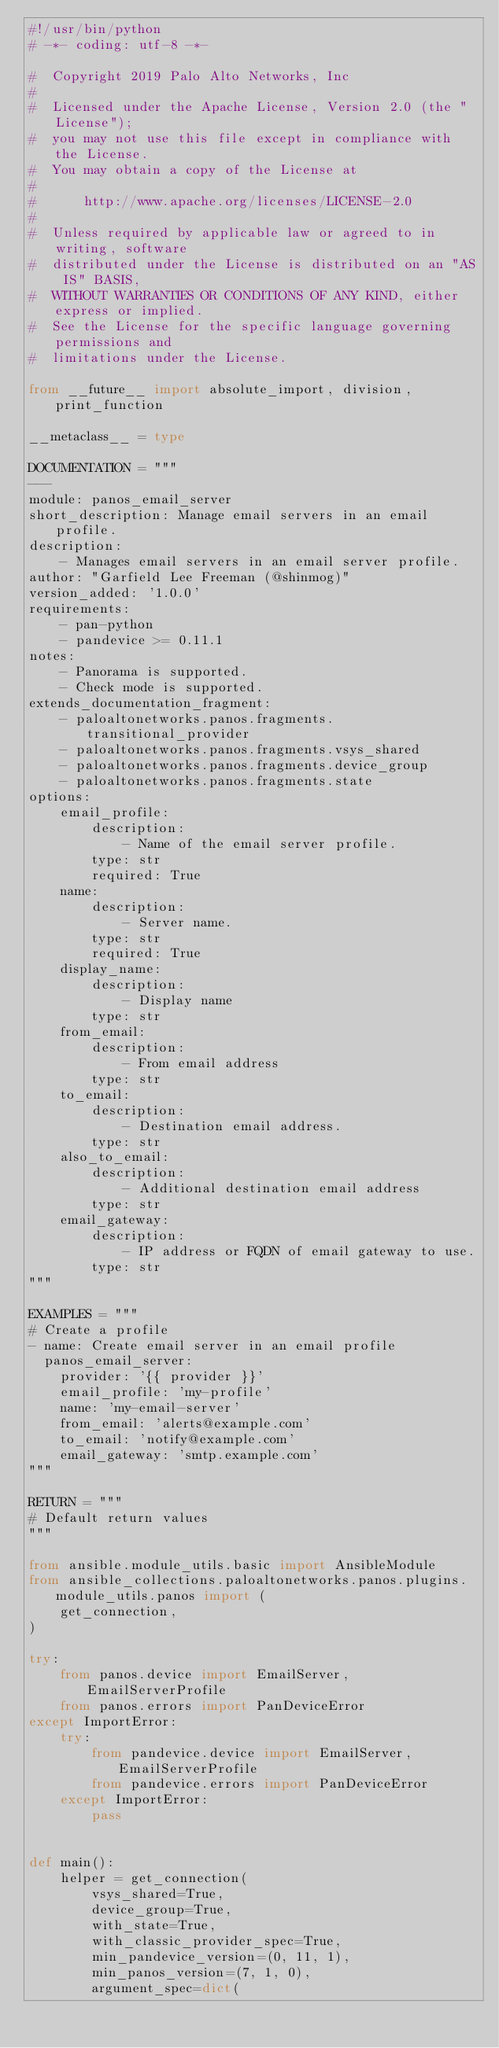<code> <loc_0><loc_0><loc_500><loc_500><_Python_>#!/usr/bin/python
# -*- coding: utf-8 -*-

#  Copyright 2019 Palo Alto Networks, Inc
#
#  Licensed under the Apache License, Version 2.0 (the "License");
#  you may not use this file except in compliance with the License.
#  You may obtain a copy of the License at
#
#      http://www.apache.org/licenses/LICENSE-2.0
#
#  Unless required by applicable law or agreed to in writing, software
#  distributed under the License is distributed on an "AS IS" BASIS,
#  WITHOUT WARRANTIES OR CONDITIONS OF ANY KIND, either express or implied.
#  See the License for the specific language governing permissions and
#  limitations under the License.

from __future__ import absolute_import, division, print_function

__metaclass__ = type

DOCUMENTATION = """
---
module: panos_email_server
short_description: Manage email servers in an email profile.
description:
    - Manages email servers in an email server profile.
author: "Garfield Lee Freeman (@shinmog)"
version_added: '1.0.0'
requirements:
    - pan-python
    - pandevice >= 0.11.1
notes:
    - Panorama is supported.
    - Check mode is supported.
extends_documentation_fragment:
    - paloaltonetworks.panos.fragments.transitional_provider
    - paloaltonetworks.panos.fragments.vsys_shared
    - paloaltonetworks.panos.fragments.device_group
    - paloaltonetworks.panos.fragments.state
options:
    email_profile:
        description:
            - Name of the email server profile.
        type: str
        required: True
    name:
        description:
            - Server name.
        type: str
        required: True
    display_name:
        description:
            - Display name
        type: str
    from_email:
        description:
            - From email address
        type: str
    to_email:
        description:
            - Destination email address.
        type: str
    also_to_email:
        description:
            - Additional destination email address
        type: str
    email_gateway:
        description:
            - IP address or FQDN of email gateway to use.
        type: str
"""

EXAMPLES = """
# Create a profile
- name: Create email server in an email profile
  panos_email_server:
    provider: '{{ provider }}'
    email_profile: 'my-profile'
    name: 'my-email-server'
    from_email: 'alerts@example.com'
    to_email: 'notify@example.com'
    email_gateway: 'smtp.example.com'
"""

RETURN = """
# Default return values
"""

from ansible.module_utils.basic import AnsibleModule
from ansible_collections.paloaltonetworks.panos.plugins.module_utils.panos import (
    get_connection,
)

try:
    from panos.device import EmailServer, EmailServerProfile
    from panos.errors import PanDeviceError
except ImportError:
    try:
        from pandevice.device import EmailServer, EmailServerProfile
        from pandevice.errors import PanDeviceError
    except ImportError:
        pass


def main():
    helper = get_connection(
        vsys_shared=True,
        device_group=True,
        with_state=True,
        with_classic_provider_spec=True,
        min_pandevice_version=(0, 11, 1),
        min_panos_version=(7, 1, 0),
        argument_spec=dict(</code> 